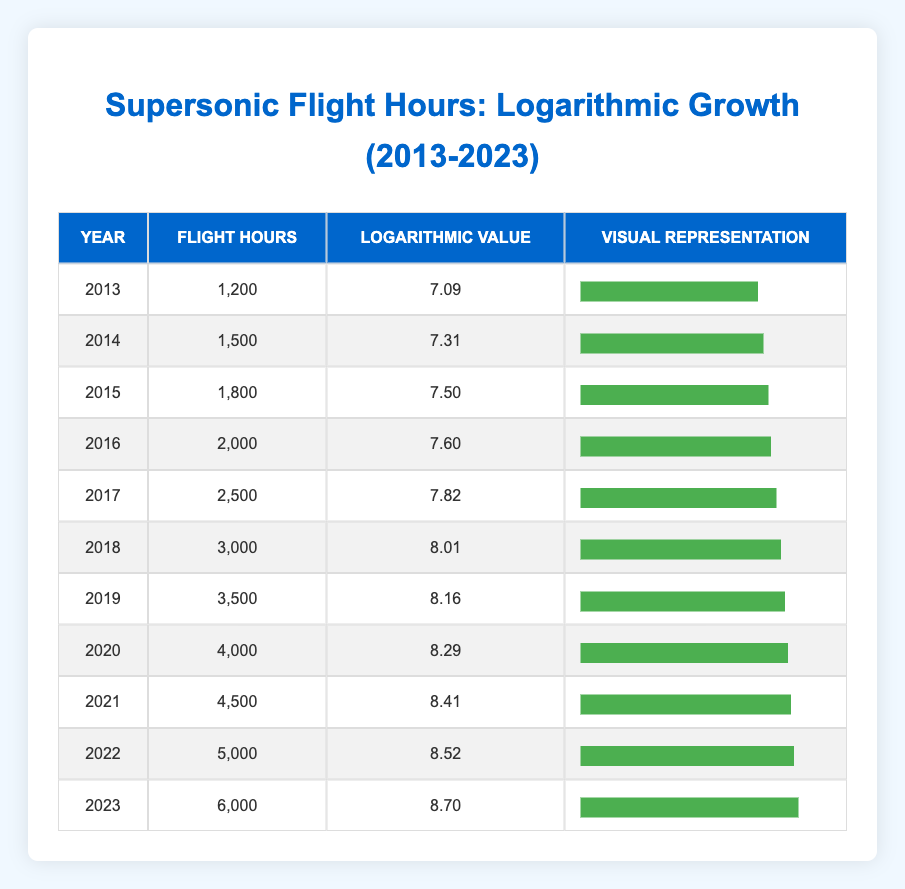What was the flight hour total in 2020? Referring to the table, the flight hours for 2020 is specified in the row for that year, where it clearly states that the flight hours are 4000.
Answer: 4000 What is the logarithmic value for the year 2015? Looking at the table and finding the row for 2015, the logarithmic value is indicated as 7.50.
Answer: 7.50 Which year saw the highest flight hours, and what were they? By examining the table from 2013 to 2023, it is evident that 2023 has the highest flight hours, posted at 6000.
Answer: 2023; 6000 What is the average flight hours over the decade? Summing the flight hours from all years: (1200 + 1500 + 1800 + 2000 + 2500 + 3000 + 3500 + 4000 + 4500 + 5000 + 6000) = 34,000. There are 11 years, so the average is 34,000 ÷ 11 = 3090.91.
Answer: 3090.91 Did the flight hours decrease in 2014 compared to 2013? Comparing the flight hours, 2013 had 1200 hours, and 2014 saw an increase to 1500 hours. Thus, it did not decrease.
Answer: No What is the total increase in flight hours from 2013 to 2023? The flight hours in 2013 were 1200 and in 2023 it was 6000. The increase is calculated as 6000 - 1200 = 4800.
Answer: 4800 In which two consecutive years was there a flight hour increase of more than 500 hours? Reviewing the table, the years 2016 to 2017 show an increase from 2000 to 2500, which is 500. However, the jumps from 2018 (3000) to 2019 (3500), and 2021 (4500) to 2022 (5000) show increases of 500 or more. Hence, these years fit the criteria: 2018 to 2019 and 2021 to 2022.
Answer: 2018 to 2019, 2021 to 2022 What was the logarithmic value for the year with the lowest flight hours? Looking through the table, the lowest flight hours occurred in 2013, which has a logarithmic value of 7.09.
Answer: 7.09 Did the logarithmic value increase consistently each year? Examining the logarithmic values from 2013 to 2023 shows that the values increased each year, indicating a consistent growth pattern.
Answer: Yes 